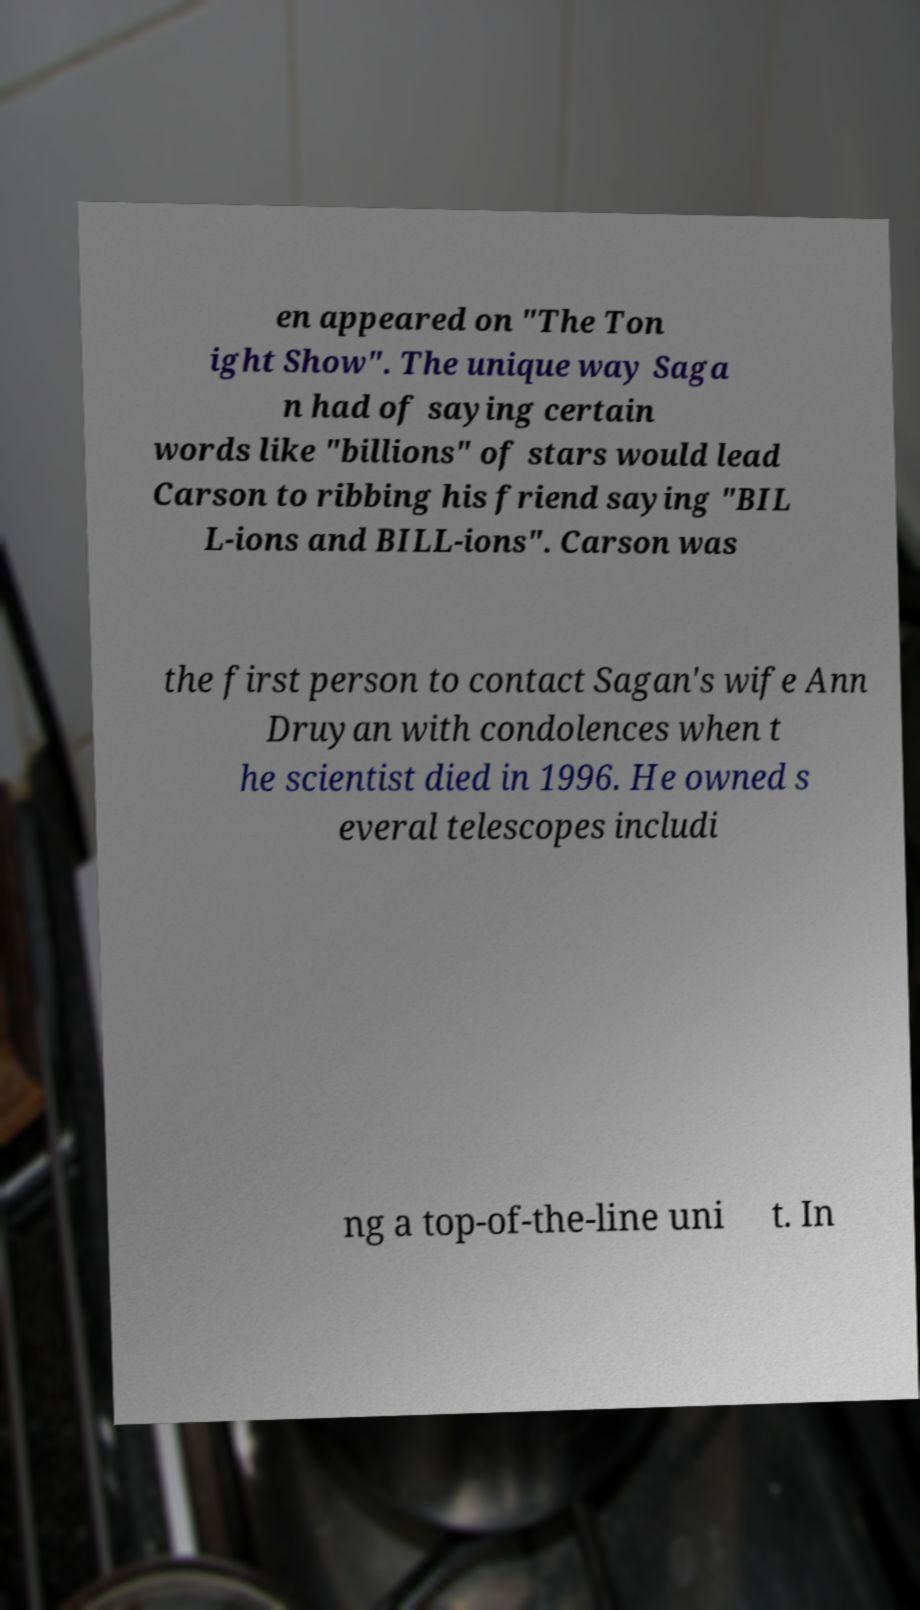Can you accurately transcribe the text from the provided image for me? en appeared on "The Ton ight Show". The unique way Saga n had of saying certain words like "billions" of stars would lead Carson to ribbing his friend saying "BIL L-ions and BILL-ions". Carson was the first person to contact Sagan's wife Ann Druyan with condolences when t he scientist died in 1996. He owned s everal telescopes includi ng a top-of-the-line uni t. In 